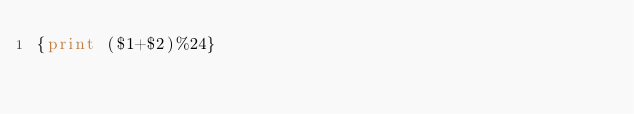Convert code to text. <code><loc_0><loc_0><loc_500><loc_500><_Awk_>{print ($1+$2)%24}
</code> 